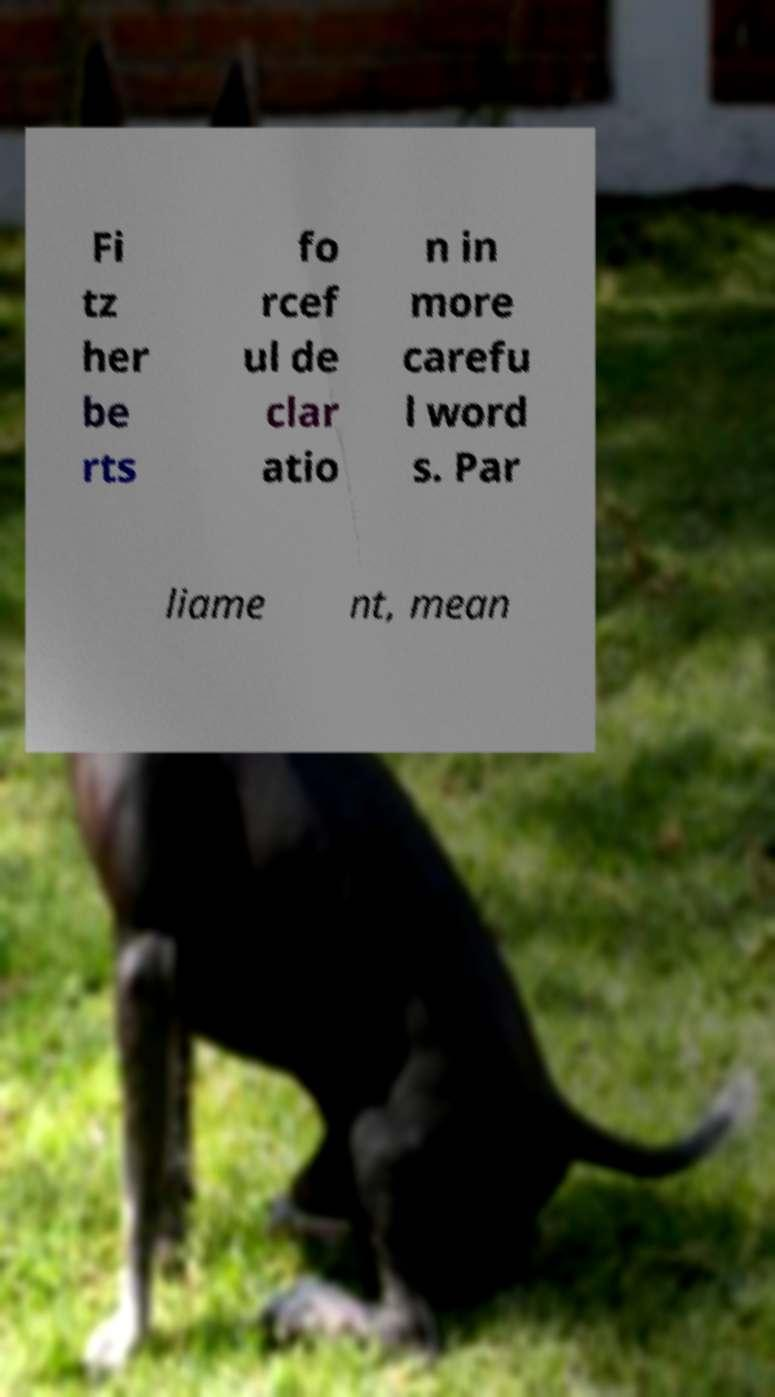Could you extract and type out the text from this image? Fi tz her be rts fo rcef ul de clar atio n in more carefu l word s. Par liame nt, mean 